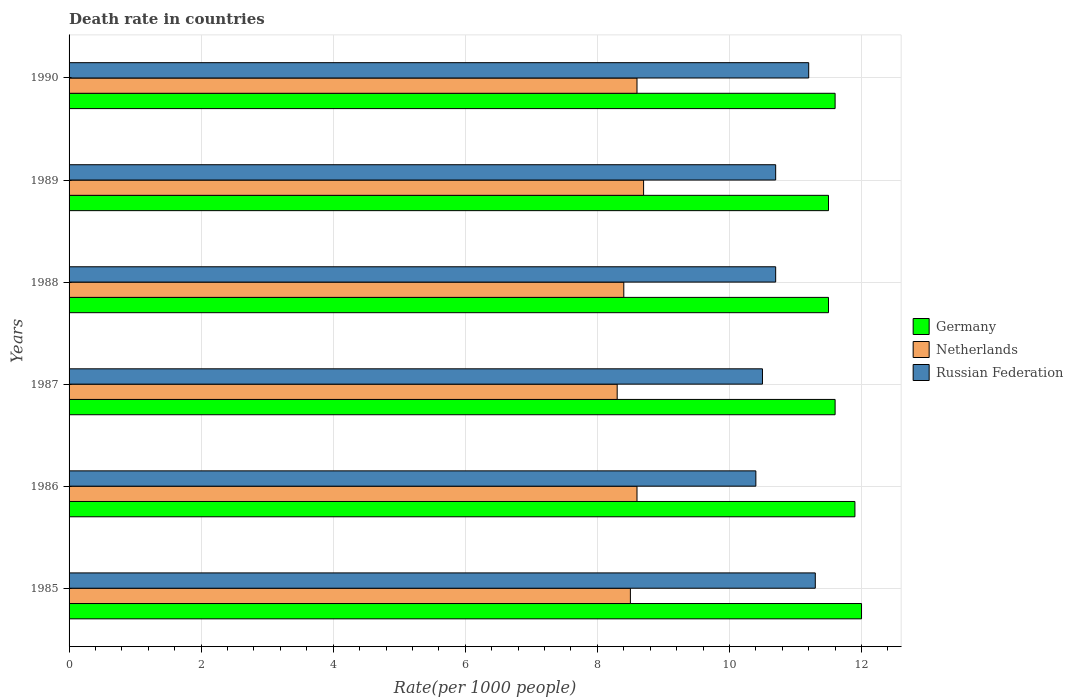How many different coloured bars are there?
Your response must be concise. 3. How many groups of bars are there?
Offer a terse response. 6. Are the number of bars on each tick of the Y-axis equal?
Keep it short and to the point. Yes. Across all years, what is the minimum death rate in Russian Federation?
Ensure brevity in your answer.  10.4. In which year was the death rate in Germany maximum?
Make the answer very short. 1985. What is the total death rate in Germany in the graph?
Your answer should be very brief. 70.1. What is the difference between the death rate in Netherlands in 1987 and that in 1989?
Your answer should be compact. -0.4. What is the difference between the death rate in Netherlands in 1990 and the death rate in Russian Federation in 1987?
Your answer should be compact. -1.9. What is the average death rate in Germany per year?
Your response must be concise. 11.68. What is the ratio of the death rate in Russian Federation in 1985 to that in 1988?
Give a very brief answer. 1.06. Is the death rate in Russian Federation in 1987 less than that in 1989?
Keep it short and to the point. Yes. Is the difference between the death rate in Russian Federation in 1985 and 1987 greater than the difference between the death rate in Germany in 1985 and 1987?
Offer a very short reply. Yes. What is the difference between the highest and the second highest death rate in Netherlands?
Give a very brief answer. 0.1. Is the sum of the death rate in Germany in 1986 and 1989 greater than the maximum death rate in Netherlands across all years?
Offer a very short reply. Yes. What does the 2nd bar from the top in 1985 represents?
Ensure brevity in your answer.  Netherlands. What does the 3rd bar from the bottom in 1990 represents?
Your response must be concise. Russian Federation. Is it the case that in every year, the sum of the death rate in Germany and death rate in Netherlands is greater than the death rate in Russian Federation?
Offer a very short reply. Yes. How many bars are there?
Keep it short and to the point. 18. Are all the bars in the graph horizontal?
Ensure brevity in your answer.  Yes. How many years are there in the graph?
Offer a very short reply. 6. What is the difference between two consecutive major ticks on the X-axis?
Your response must be concise. 2. Are the values on the major ticks of X-axis written in scientific E-notation?
Your response must be concise. No. Does the graph contain any zero values?
Your response must be concise. No. How many legend labels are there?
Provide a short and direct response. 3. How are the legend labels stacked?
Provide a short and direct response. Vertical. What is the title of the graph?
Provide a succinct answer. Death rate in countries. Does "Europe(all income levels)" appear as one of the legend labels in the graph?
Your response must be concise. No. What is the label or title of the X-axis?
Provide a succinct answer. Rate(per 1000 people). What is the Rate(per 1000 people) in Germany in 1985?
Make the answer very short. 12. What is the Rate(per 1000 people) of Netherlands in 1985?
Keep it short and to the point. 8.5. What is the Rate(per 1000 people) in Russian Federation in 1986?
Offer a terse response. 10.4. What is the Rate(per 1000 people) in Germany in 1987?
Offer a very short reply. 11.6. What is the Rate(per 1000 people) in Netherlands in 1987?
Provide a succinct answer. 8.3. What is the Rate(per 1000 people) in Russian Federation in 1987?
Give a very brief answer. 10.5. What is the Rate(per 1000 people) of Netherlands in 1988?
Your response must be concise. 8.4. What is the Rate(per 1000 people) of Russian Federation in 1988?
Keep it short and to the point. 10.7. What is the Rate(per 1000 people) of Germany in 1989?
Give a very brief answer. 11.5. What is the Rate(per 1000 people) in Germany in 1990?
Your answer should be compact. 11.6. What is the Rate(per 1000 people) of Netherlands in 1990?
Give a very brief answer. 8.6. Across all years, what is the minimum Rate(per 1000 people) of Russian Federation?
Give a very brief answer. 10.4. What is the total Rate(per 1000 people) in Germany in the graph?
Your answer should be very brief. 70.1. What is the total Rate(per 1000 people) in Netherlands in the graph?
Offer a very short reply. 51.1. What is the total Rate(per 1000 people) in Russian Federation in the graph?
Make the answer very short. 64.8. What is the difference between the Rate(per 1000 people) in Netherlands in 1985 and that in 1986?
Give a very brief answer. -0.1. What is the difference between the Rate(per 1000 people) of Russian Federation in 1985 and that in 1986?
Provide a succinct answer. 0.9. What is the difference between the Rate(per 1000 people) in Russian Federation in 1985 and that in 1987?
Your answer should be compact. 0.8. What is the difference between the Rate(per 1000 people) of Russian Federation in 1985 and that in 1988?
Your answer should be compact. 0.6. What is the difference between the Rate(per 1000 people) in Netherlands in 1985 and that in 1989?
Offer a terse response. -0.2. What is the difference between the Rate(per 1000 people) of Russian Federation in 1985 and that in 1989?
Your answer should be compact. 0.6. What is the difference between the Rate(per 1000 people) of Germany in 1985 and that in 1990?
Provide a short and direct response. 0.4. What is the difference between the Rate(per 1000 people) of Netherlands in 1985 and that in 1990?
Provide a succinct answer. -0.1. What is the difference between the Rate(per 1000 people) of Russian Federation in 1985 and that in 1990?
Ensure brevity in your answer.  0.1. What is the difference between the Rate(per 1000 people) of Netherlands in 1986 and that in 1987?
Keep it short and to the point. 0.3. What is the difference between the Rate(per 1000 people) in Germany in 1986 and that in 1988?
Offer a very short reply. 0.4. What is the difference between the Rate(per 1000 people) in Russian Federation in 1986 and that in 1988?
Your answer should be very brief. -0.3. What is the difference between the Rate(per 1000 people) in Netherlands in 1986 and that in 1989?
Ensure brevity in your answer.  -0.1. What is the difference between the Rate(per 1000 people) of Russian Federation in 1986 and that in 1989?
Make the answer very short. -0.3. What is the difference between the Rate(per 1000 people) in Germany in 1987 and that in 1989?
Your answer should be very brief. 0.1. What is the difference between the Rate(per 1000 people) of Netherlands in 1987 and that in 1989?
Provide a succinct answer. -0.4. What is the difference between the Rate(per 1000 people) in Russian Federation in 1987 and that in 1989?
Ensure brevity in your answer.  -0.2. What is the difference between the Rate(per 1000 people) in Germany in 1987 and that in 1990?
Ensure brevity in your answer.  0. What is the difference between the Rate(per 1000 people) in Netherlands in 1987 and that in 1990?
Provide a short and direct response. -0.3. What is the difference between the Rate(per 1000 people) of Russian Federation in 1987 and that in 1990?
Offer a terse response. -0.7. What is the difference between the Rate(per 1000 people) of Russian Federation in 1988 and that in 1989?
Give a very brief answer. 0. What is the difference between the Rate(per 1000 people) in Germany in 1988 and that in 1990?
Keep it short and to the point. -0.1. What is the difference between the Rate(per 1000 people) of Russian Federation in 1988 and that in 1990?
Offer a very short reply. -0.5. What is the difference between the Rate(per 1000 people) in Russian Federation in 1989 and that in 1990?
Ensure brevity in your answer.  -0.5. What is the difference between the Rate(per 1000 people) in Germany in 1985 and the Rate(per 1000 people) in Netherlands in 1986?
Offer a very short reply. 3.4. What is the difference between the Rate(per 1000 people) of Germany in 1985 and the Rate(per 1000 people) of Russian Federation in 1986?
Offer a terse response. 1.6. What is the difference between the Rate(per 1000 people) of Germany in 1985 and the Rate(per 1000 people) of Russian Federation in 1987?
Give a very brief answer. 1.5. What is the difference between the Rate(per 1000 people) in Netherlands in 1985 and the Rate(per 1000 people) in Russian Federation in 1987?
Keep it short and to the point. -2. What is the difference between the Rate(per 1000 people) in Germany in 1985 and the Rate(per 1000 people) in Netherlands in 1988?
Make the answer very short. 3.6. What is the difference between the Rate(per 1000 people) of Germany in 1985 and the Rate(per 1000 people) of Russian Federation in 1988?
Provide a short and direct response. 1.3. What is the difference between the Rate(per 1000 people) of Germany in 1985 and the Rate(per 1000 people) of Netherlands in 1989?
Offer a very short reply. 3.3. What is the difference between the Rate(per 1000 people) in Germany in 1985 and the Rate(per 1000 people) in Russian Federation in 1989?
Provide a short and direct response. 1.3. What is the difference between the Rate(per 1000 people) in Netherlands in 1985 and the Rate(per 1000 people) in Russian Federation in 1989?
Ensure brevity in your answer.  -2.2. What is the difference between the Rate(per 1000 people) of Germany in 1985 and the Rate(per 1000 people) of Russian Federation in 1990?
Offer a very short reply. 0.8. What is the difference between the Rate(per 1000 people) in Germany in 1986 and the Rate(per 1000 people) in Russian Federation in 1988?
Your answer should be compact. 1.2. What is the difference between the Rate(per 1000 people) in Germany in 1986 and the Rate(per 1000 people) in Netherlands in 1989?
Make the answer very short. 3.2. What is the difference between the Rate(per 1000 people) of Germany in 1986 and the Rate(per 1000 people) of Russian Federation in 1990?
Give a very brief answer. 0.7. What is the difference between the Rate(per 1000 people) in Netherlands in 1986 and the Rate(per 1000 people) in Russian Federation in 1990?
Your answer should be compact. -2.6. What is the difference between the Rate(per 1000 people) in Germany in 1987 and the Rate(per 1000 people) in Netherlands in 1988?
Offer a terse response. 3.2. What is the difference between the Rate(per 1000 people) of Netherlands in 1987 and the Rate(per 1000 people) of Russian Federation in 1988?
Your answer should be very brief. -2.4. What is the difference between the Rate(per 1000 people) in Netherlands in 1987 and the Rate(per 1000 people) in Russian Federation in 1989?
Offer a very short reply. -2.4. What is the difference between the Rate(per 1000 people) in Germany in 1987 and the Rate(per 1000 people) in Russian Federation in 1990?
Provide a short and direct response. 0.4. What is the difference between the Rate(per 1000 people) of Netherlands in 1988 and the Rate(per 1000 people) of Russian Federation in 1989?
Offer a terse response. -2.3. What is the difference between the Rate(per 1000 people) of Germany in 1989 and the Rate(per 1000 people) of Netherlands in 1990?
Provide a short and direct response. 2.9. What is the difference between the Rate(per 1000 people) in Germany in 1989 and the Rate(per 1000 people) in Russian Federation in 1990?
Make the answer very short. 0.3. What is the difference between the Rate(per 1000 people) in Netherlands in 1989 and the Rate(per 1000 people) in Russian Federation in 1990?
Your response must be concise. -2.5. What is the average Rate(per 1000 people) in Germany per year?
Keep it short and to the point. 11.68. What is the average Rate(per 1000 people) of Netherlands per year?
Make the answer very short. 8.52. In the year 1985, what is the difference between the Rate(per 1000 people) of Germany and Rate(per 1000 people) of Russian Federation?
Keep it short and to the point. 0.7. In the year 1986, what is the difference between the Rate(per 1000 people) of Germany and Rate(per 1000 people) of Russian Federation?
Make the answer very short. 1.5. In the year 1987, what is the difference between the Rate(per 1000 people) of Germany and Rate(per 1000 people) of Russian Federation?
Provide a succinct answer. 1.1. In the year 1990, what is the difference between the Rate(per 1000 people) in Germany and Rate(per 1000 people) in Netherlands?
Offer a terse response. 3. What is the ratio of the Rate(per 1000 people) in Germany in 1985 to that in 1986?
Ensure brevity in your answer.  1.01. What is the ratio of the Rate(per 1000 people) of Netherlands in 1985 to that in 1986?
Make the answer very short. 0.99. What is the ratio of the Rate(per 1000 people) of Russian Federation in 1985 to that in 1986?
Provide a short and direct response. 1.09. What is the ratio of the Rate(per 1000 people) in Germany in 1985 to that in 1987?
Provide a short and direct response. 1.03. What is the ratio of the Rate(per 1000 people) of Netherlands in 1985 to that in 1987?
Keep it short and to the point. 1.02. What is the ratio of the Rate(per 1000 people) in Russian Federation in 1985 to that in 1987?
Your answer should be very brief. 1.08. What is the ratio of the Rate(per 1000 people) in Germany in 1985 to that in 1988?
Ensure brevity in your answer.  1.04. What is the ratio of the Rate(per 1000 people) of Netherlands in 1985 to that in 1988?
Keep it short and to the point. 1.01. What is the ratio of the Rate(per 1000 people) of Russian Federation in 1985 to that in 1988?
Your response must be concise. 1.06. What is the ratio of the Rate(per 1000 people) in Germany in 1985 to that in 1989?
Ensure brevity in your answer.  1.04. What is the ratio of the Rate(per 1000 people) of Russian Federation in 1985 to that in 1989?
Your response must be concise. 1.06. What is the ratio of the Rate(per 1000 people) in Germany in 1985 to that in 1990?
Offer a very short reply. 1.03. What is the ratio of the Rate(per 1000 people) of Netherlands in 1985 to that in 1990?
Make the answer very short. 0.99. What is the ratio of the Rate(per 1000 people) of Russian Federation in 1985 to that in 1990?
Provide a short and direct response. 1.01. What is the ratio of the Rate(per 1000 people) of Germany in 1986 to that in 1987?
Your answer should be very brief. 1.03. What is the ratio of the Rate(per 1000 people) in Netherlands in 1986 to that in 1987?
Provide a short and direct response. 1.04. What is the ratio of the Rate(per 1000 people) of Russian Federation in 1986 to that in 1987?
Your response must be concise. 0.99. What is the ratio of the Rate(per 1000 people) of Germany in 1986 to that in 1988?
Provide a succinct answer. 1.03. What is the ratio of the Rate(per 1000 people) in Netherlands in 1986 to that in 1988?
Give a very brief answer. 1.02. What is the ratio of the Rate(per 1000 people) in Germany in 1986 to that in 1989?
Make the answer very short. 1.03. What is the ratio of the Rate(per 1000 people) in Netherlands in 1986 to that in 1989?
Your answer should be compact. 0.99. What is the ratio of the Rate(per 1000 people) in Russian Federation in 1986 to that in 1989?
Offer a terse response. 0.97. What is the ratio of the Rate(per 1000 people) in Germany in 1986 to that in 1990?
Your answer should be very brief. 1.03. What is the ratio of the Rate(per 1000 people) in Netherlands in 1986 to that in 1990?
Offer a very short reply. 1. What is the ratio of the Rate(per 1000 people) in Russian Federation in 1986 to that in 1990?
Your answer should be very brief. 0.93. What is the ratio of the Rate(per 1000 people) in Germany in 1987 to that in 1988?
Your answer should be very brief. 1.01. What is the ratio of the Rate(per 1000 people) of Netherlands in 1987 to that in 1988?
Offer a terse response. 0.99. What is the ratio of the Rate(per 1000 people) of Russian Federation in 1987 to that in 1988?
Your answer should be compact. 0.98. What is the ratio of the Rate(per 1000 people) of Germany in 1987 to that in 1989?
Make the answer very short. 1.01. What is the ratio of the Rate(per 1000 people) in Netherlands in 1987 to that in 1989?
Provide a succinct answer. 0.95. What is the ratio of the Rate(per 1000 people) in Russian Federation in 1987 to that in 1989?
Make the answer very short. 0.98. What is the ratio of the Rate(per 1000 people) in Germany in 1987 to that in 1990?
Keep it short and to the point. 1. What is the ratio of the Rate(per 1000 people) in Netherlands in 1987 to that in 1990?
Keep it short and to the point. 0.97. What is the ratio of the Rate(per 1000 people) of Russian Federation in 1987 to that in 1990?
Ensure brevity in your answer.  0.94. What is the ratio of the Rate(per 1000 people) in Netherlands in 1988 to that in 1989?
Offer a very short reply. 0.97. What is the ratio of the Rate(per 1000 people) of Russian Federation in 1988 to that in 1989?
Keep it short and to the point. 1. What is the ratio of the Rate(per 1000 people) of Netherlands in 1988 to that in 1990?
Your answer should be very brief. 0.98. What is the ratio of the Rate(per 1000 people) of Russian Federation in 1988 to that in 1990?
Offer a terse response. 0.96. What is the ratio of the Rate(per 1000 people) in Germany in 1989 to that in 1990?
Ensure brevity in your answer.  0.99. What is the ratio of the Rate(per 1000 people) in Netherlands in 1989 to that in 1990?
Your answer should be compact. 1.01. What is the ratio of the Rate(per 1000 people) of Russian Federation in 1989 to that in 1990?
Your answer should be compact. 0.96. What is the difference between the highest and the second highest Rate(per 1000 people) in Russian Federation?
Keep it short and to the point. 0.1. What is the difference between the highest and the lowest Rate(per 1000 people) of Germany?
Make the answer very short. 0.5. What is the difference between the highest and the lowest Rate(per 1000 people) of Netherlands?
Provide a succinct answer. 0.4. 